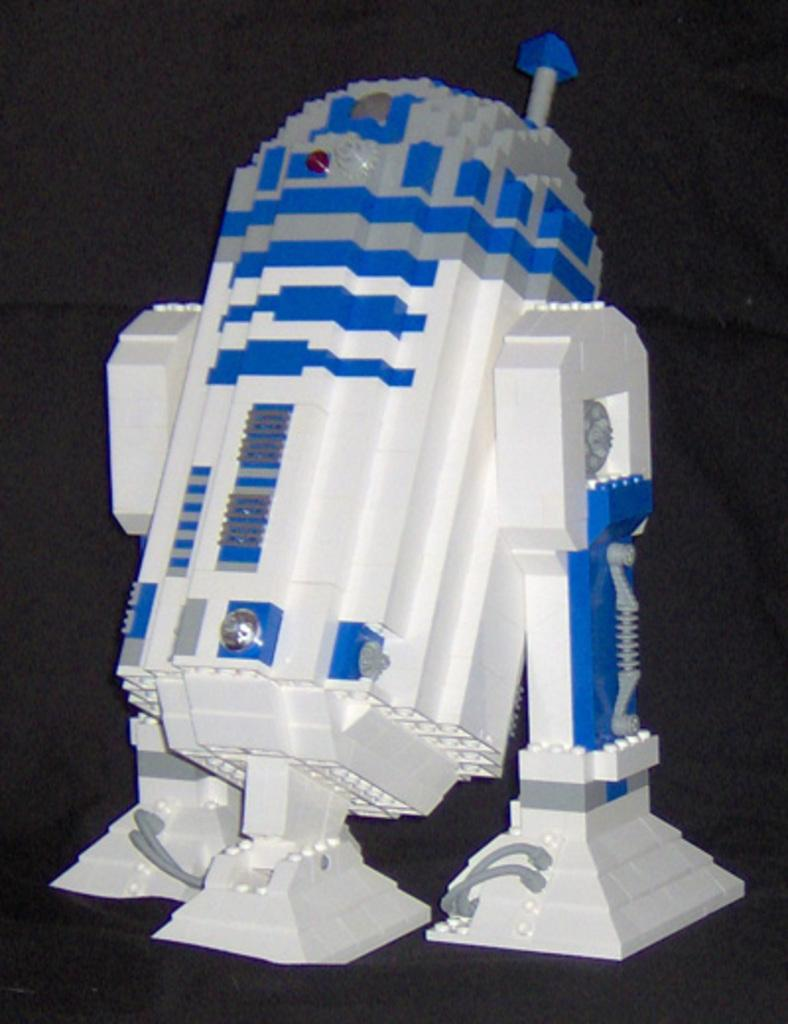What type of toy is featured in the image? There is Lego in the image. What color is the background of the image? The background of the image is black. What type of protest is taking place in the image? There is no protest present in the image; it features Lego and a black background. What type of calculator is visible in the image? There is no calculator present in the image. 